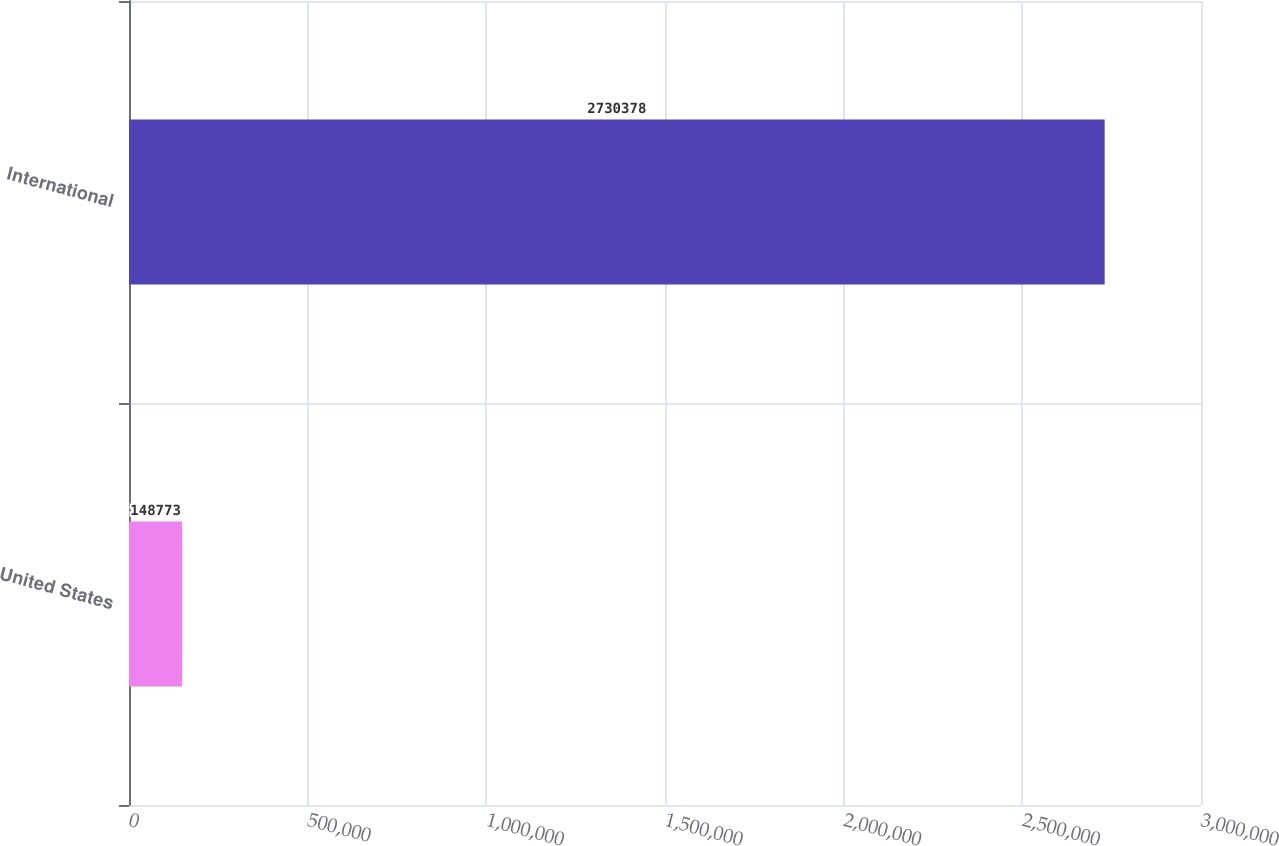Convert chart to OTSL. <chart><loc_0><loc_0><loc_500><loc_500><bar_chart><fcel>United States<fcel>International<nl><fcel>148773<fcel>2.73038e+06<nl></chart> 